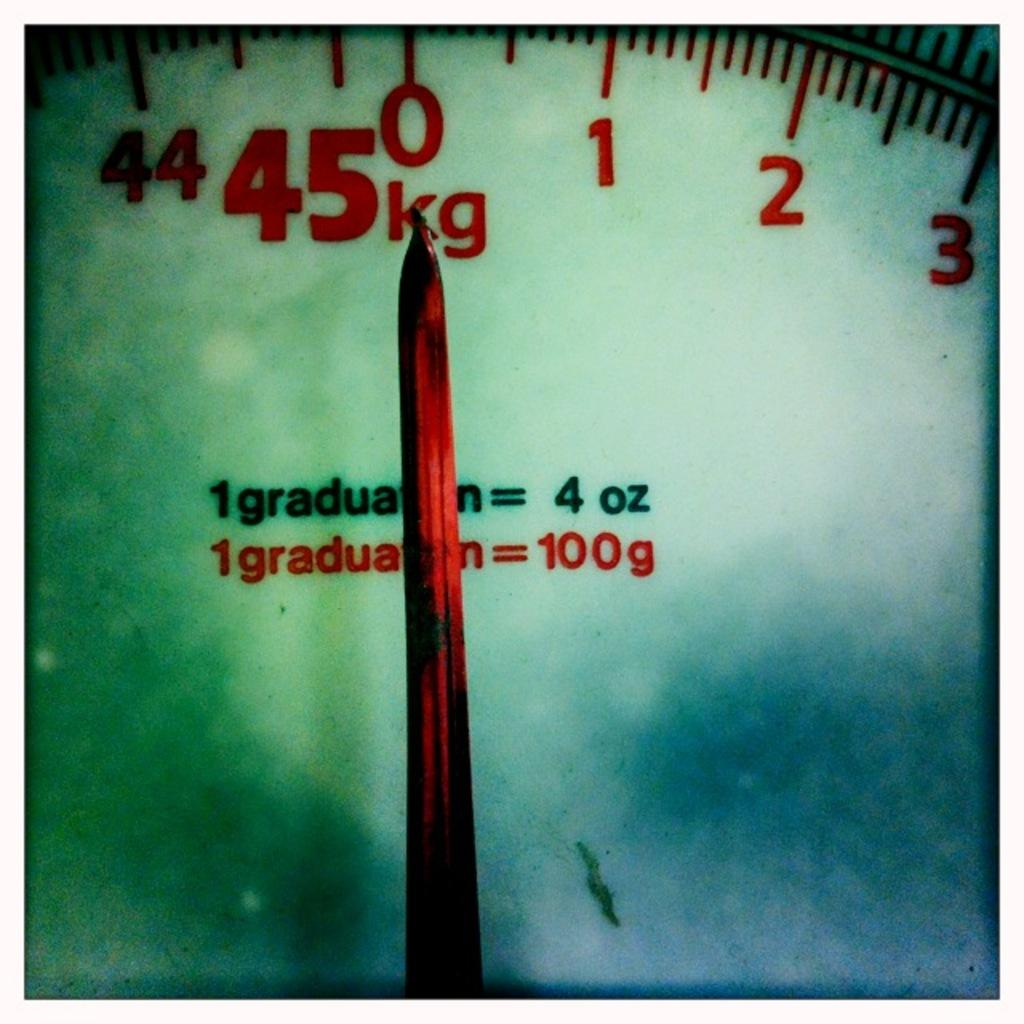<image>
Offer a succinct explanation of the picture presented. A weight scale that is set and zero and measures in kilograms. 